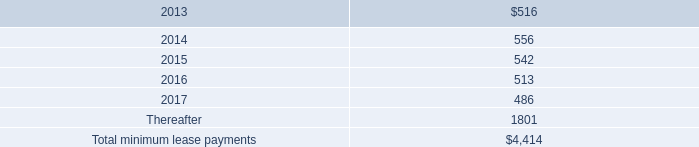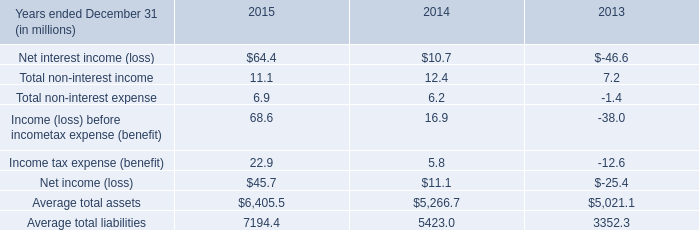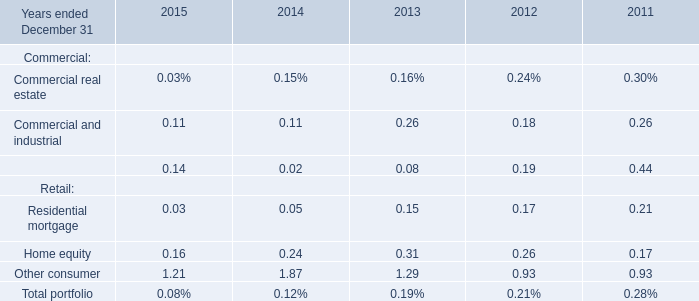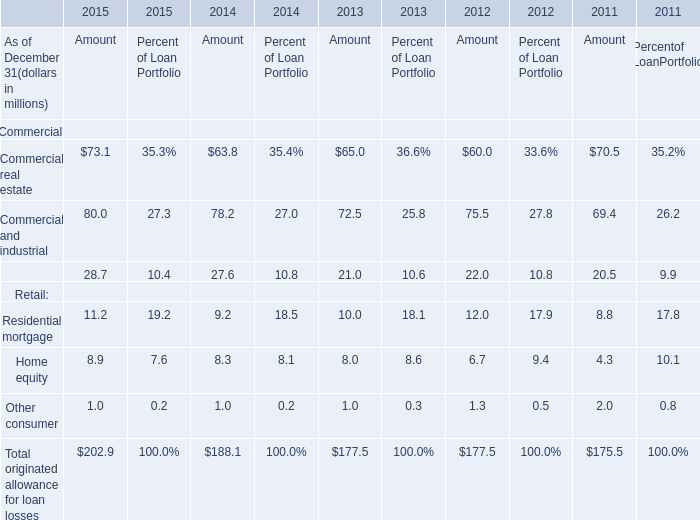What was the average value of Commercial real estate, Commercial and industrial, Equipment financing in 2015 ? (in million) 
Computations: (((73.1 + 80) + 28.7) / 3)
Answer: 60.6. 